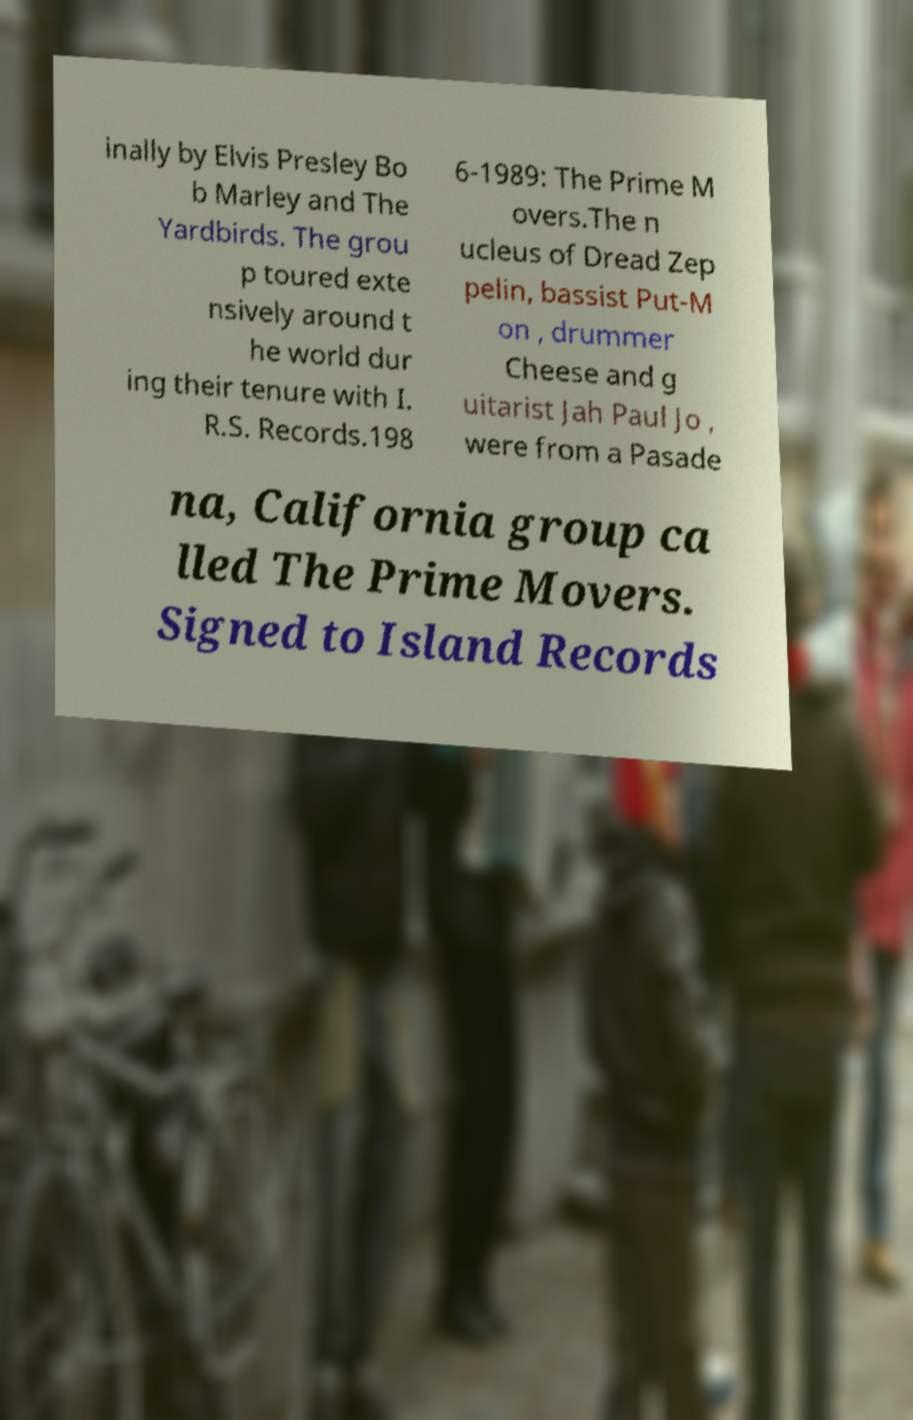Could you extract and type out the text from this image? inally by Elvis Presley Bo b Marley and The Yardbirds. The grou p toured exte nsively around t he world dur ing their tenure with I. R.S. Records.198 6-1989: The Prime M overs.The n ucleus of Dread Zep pelin, bassist Put-M on , drummer Cheese and g uitarist Jah Paul Jo , were from a Pasade na, California group ca lled The Prime Movers. Signed to Island Records 